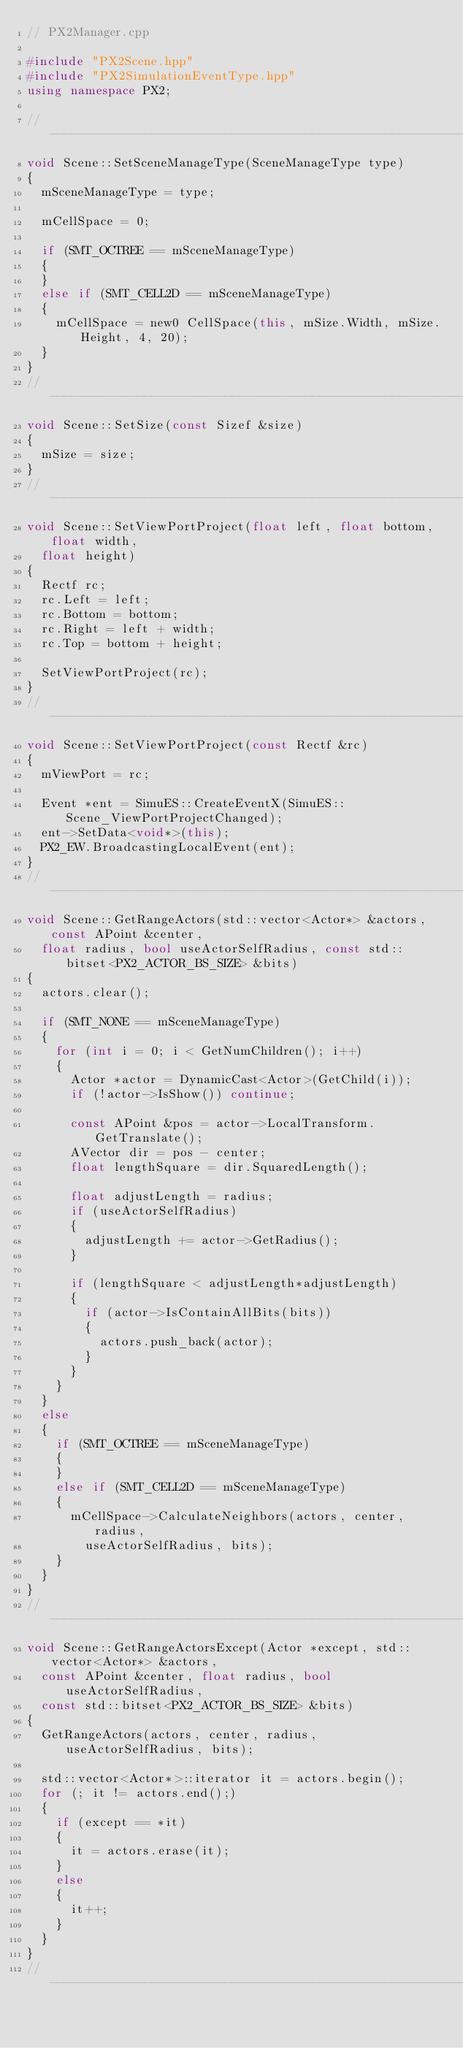<code> <loc_0><loc_0><loc_500><loc_500><_C++_>// PX2Manager.cpp

#include "PX2Scene.hpp"
#include "PX2SimulationEventType.hpp"
using namespace PX2;

//----------------------------------------------------------------------------
void Scene::SetSceneManageType(SceneManageType type)
{
	mSceneManageType = type;

	mCellSpace = 0;

	if (SMT_OCTREE == mSceneManageType)
	{
	}
	else if (SMT_CELL2D == mSceneManageType)
	{
		mCellSpace = new0 CellSpace(this, mSize.Width, mSize.Height, 4, 20);
	}
}
//----------------------------------------------------------------------------
void Scene::SetSize(const Sizef &size)
{
	mSize = size;
}
//----------------------------------------------------------------------------
void Scene::SetViewPortProject(float left, float bottom, float width, 
	float height)
{
	Rectf rc;
	rc.Left = left;
	rc.Bottom = bottom;
	rc.Right = left + width;
	rc.Top = bottom + height;

	SetViewPortProject(rc);
}
//----------------------------------------------------------------------------
void Scene::SetViewPortProject(const Rectf &rc)
{
	mViewPort = rc;

	Event *ent = SimuES::CreateEventX(SimuES::Scene_ViewPortProjectChanged);
	ent->SetData<void*>(this);
	PX2_EW.BroadcastingLocalEvent(ent);
}
//----------------------------------------------------------------------------
void Scene::GetRangeActors(std::vector<Actor*> &actors, const APoint &center,
	float radius, bool useActorSelfRadius, const std::bitset<PX2_ACTOR_BS_SIZE> &bits)
{
	actors.clear();

	if (SMT_NONE == mSceneManageType)
	{
		for (int i = 0; i < GetNumChildren(); i++)
		{
			Actor *actor = DynamicCast<Actor>(GetChild(i));
			if (!actor->IsShow()) continue;

			const APoint &pos = actor->LocalTransform.GetTranslate();
			AVector dir = pos - center;
			float lengthSquare = dir.SquaredLength();

			float adjustLength = radius;
			if (useActorSelfRadius)
			{
				adjustLength += actor->GetRadius();
			}

			if (lengthSquare < adjustLength*adjustLength)
			{
				if (actor->IsContainAllBits(bits))
				{
					actors.push_back(actor);
				}
			}
		}
	}
	else
	{
		if (SMT_OCTREE == mSceneManageType)
		{
		}
		else if (SMT_CELL2D == mSceneManageType)
		{
			mCellSpace->CalculateNeighbors(actors, center, radius,
				useActorSelfRadius, bits);
		}
	}
}
//----------------------------------------------------------------------------
void Scene::GetRangeActorsExcept(Actor *except, std::vector<Actor*> &actors,
	const APoint &center, float radius, bool useActorSelfRadius,
	const std::bitset<PX2_ACTOR_BS_SIZE> &bits)
{
	GetRangeActors(actors, center, radius, useActorSelfRadius, bits);

	std::vector<Actor*>::iterator it = actors.begin();
	for (; it != actors.end();)
	{
		if (except == *it)
		{
			it = actors.erase(it);
		}
		else
		{
			it++;
		}
	}
}
//----------------------------------------------------------------------------</code> 